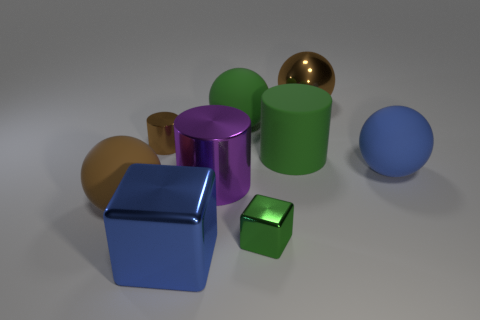Do the tiny shiny cube and the big matte cylinder have the same color?
Offer a terse response. Yes. How many small shiny objects are both behind the small green block and right of the green sphere?
Your answer should be very brief. 0. What number of green rubber objects are behind the blue thing in front of the brown object in front of the brown metallic cylinder?
Provide a short and direct response. 2. What size is the ball that is the same color as the big matte cylinder?
Keep it short and to the point. Large. What shape is the small green metal object?
Provide a short and direct response. Cube. What number of purple cylinders are the same material as the tiny brown object?
Your response must be concise. 1. There is another cylinder that is the same material as the brown cylinder; what color is it?
Ensure brevity in your answer.  Purple. There is a blue sphere; does it have the same size as the metallic cylinder that is to the right of the large block?
Offer a very short reply. Yes. What material is the blue object that is in front of the rubber object that is on the right side of the big brown sphere behind the big green matte ball made of?
Offer a very short reply. Metal. How many objects are either tiny cyan blocks or large brown shiny objects?
Your response must be concise. 1. 